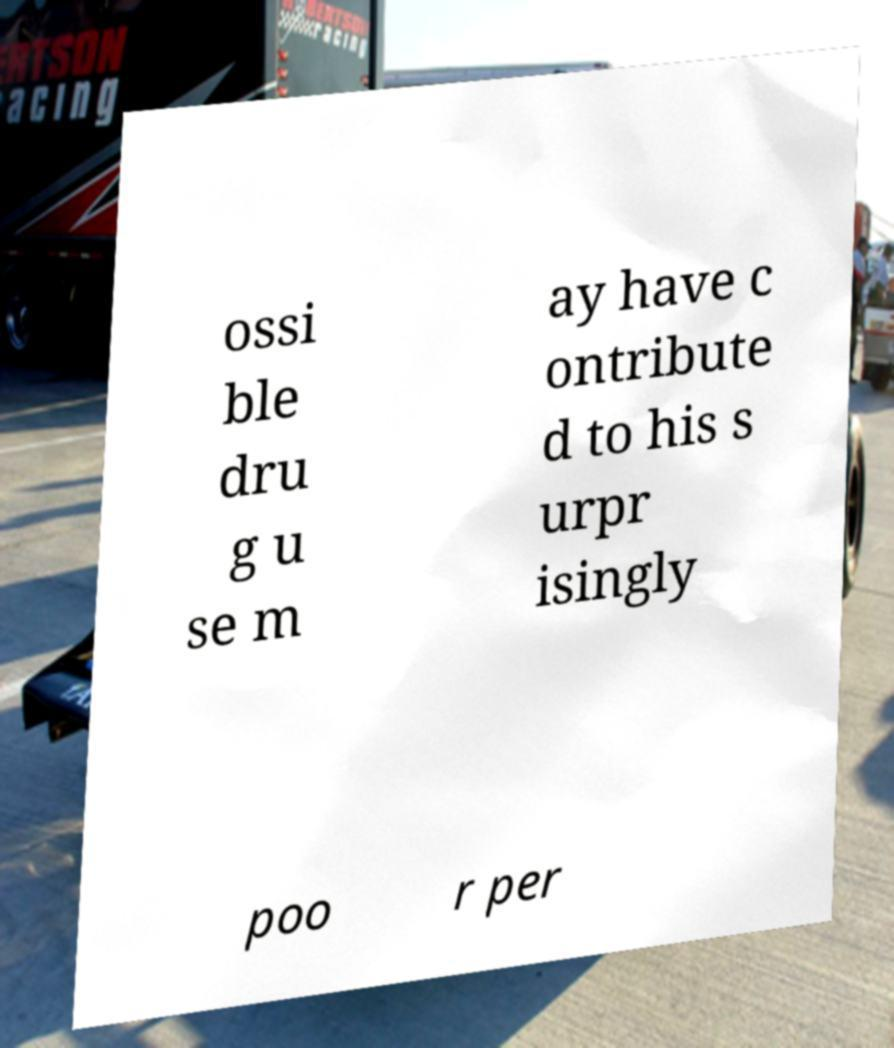Can you accurately transcribe the text from the provided image for me? ossi ble dru g u se m ay have c ontribute d to his s urpr isingly poo r per 